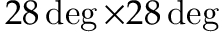Convert formula to latex. <formula><loc_0><loc_0><loc_500><loc_500>2 8 \deg \times 2 8 \deg</formula> 